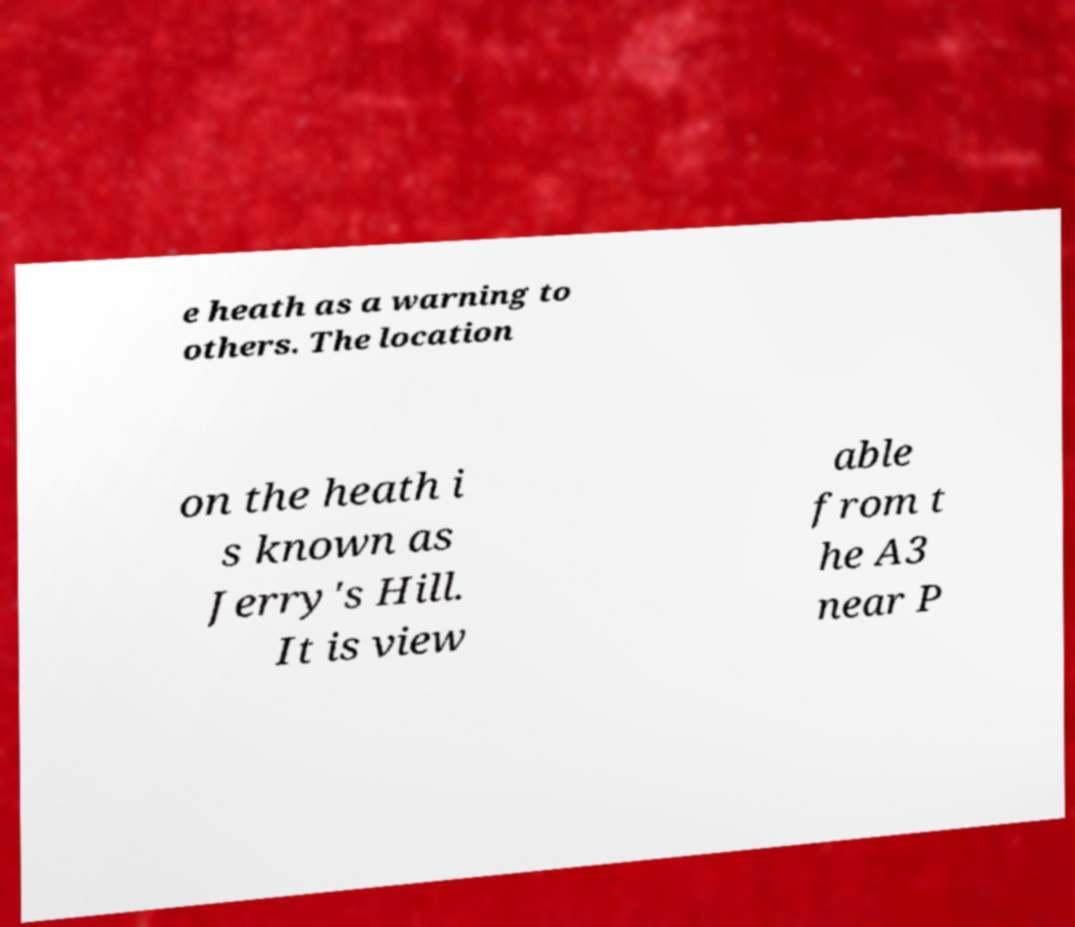For documentation purposes, I need the text within this image transcribed. Could you provide that? e heath as a warning to others. The location on the heath i s known as Jerry's Hill. It is view able from t he A3 near P 